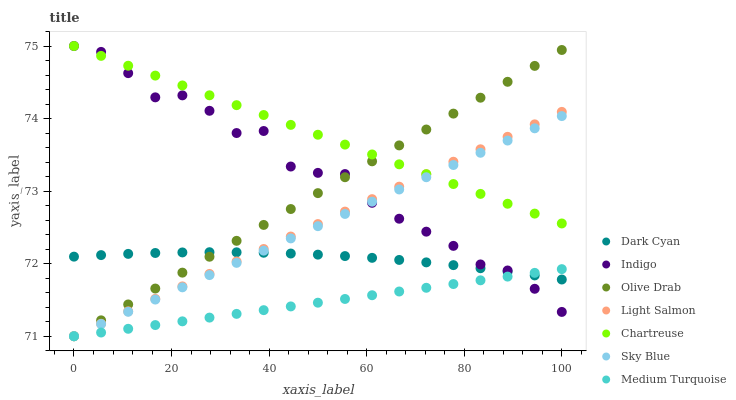Does Medium Turquoise have the minimum area under the curve?
Answer yes or no. Yes. Does Chartreuse have the maximum area under the curve?
Answer yes or no. Yes. Does Indigo have the minimum area under the curve?
Answer yes or no. No. Does Indigo have the maximum area under the curve?
Answer yes or no. No. Is Sky Blue the smoothest?
Answer yes or no. Yes. Is Indigo the roughest?
Answer yes or no. Yes. Is Chartreuse the smoothest?
Answer yes or no. No. Is Chartreuse the roughest?
Answer yes or no. No. Does Light Salmon have the lowest value?
Answer yes or no. Yes. Does Indigo have the lowest value?
Answer yes or no. No. Does Chartreuse have the highest value?
Answer yes or no. Yes. Does Medium Turquoise have the highest value?
Answer yes or no. No. Is Medium Turquoise less than Chartreuse?
Answer yes or no. Yes. Is Chartreuse greater than Medium Turquoise?
Answer yes or no. Yes. Does Dark Cyan intersect Medium Turquoise?
Answer yes or no. Yes. Is Dark Cyan less than Medium Turquoise?
Answer yes or no. No. Is Dark Cyan greater than Medium Turquoise?
Answer yes or no. No. Does Medium Turquoise intersect Chartreuse?
Answer yes or no. No. 